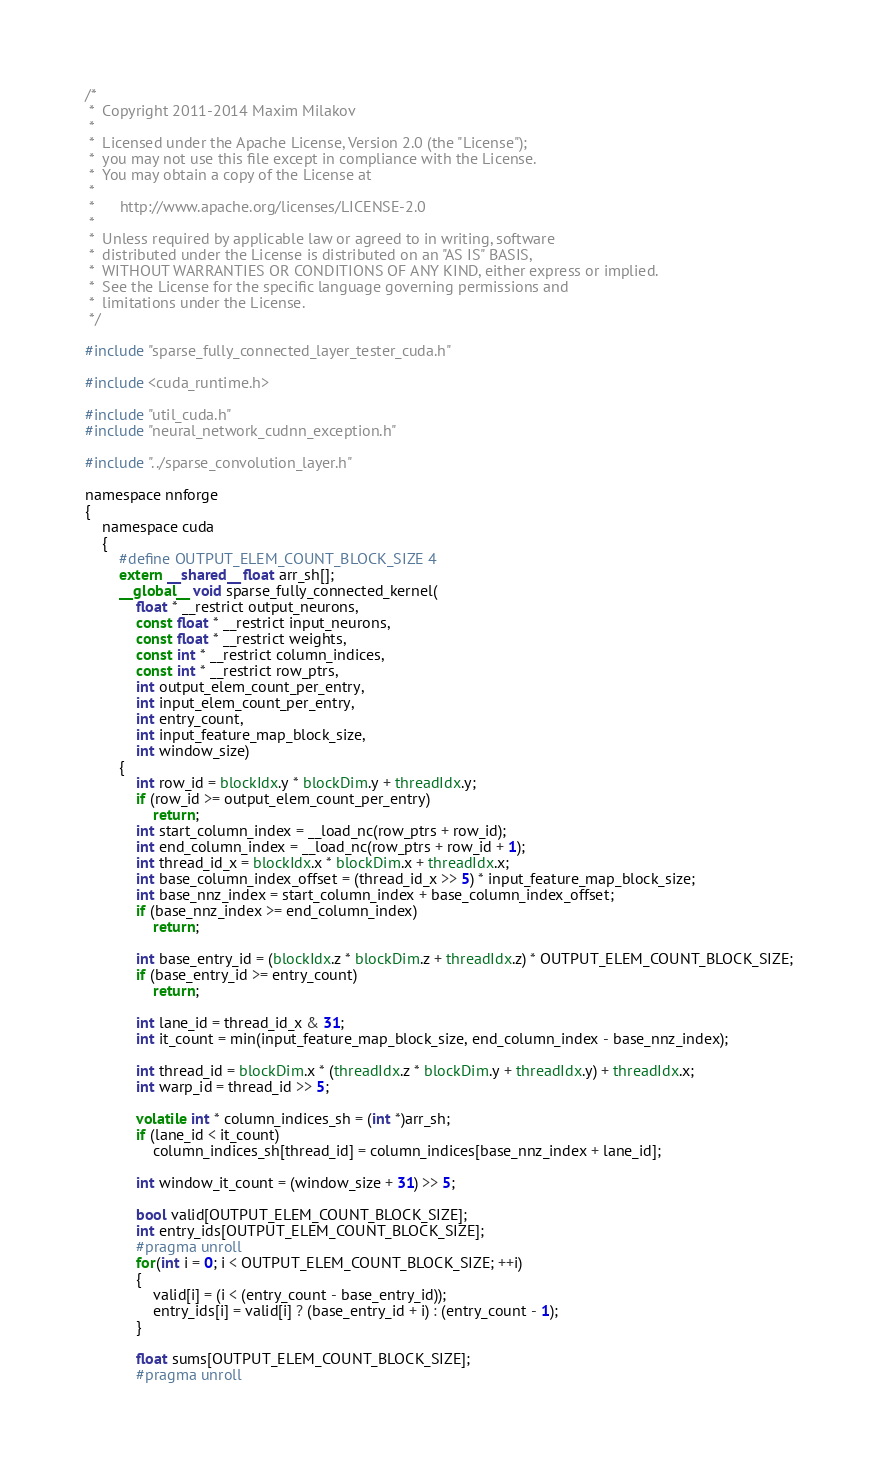Convert code to text. <code><loc_0><loc_0><loc_500><loc_500><_Cuda_>/*
 *  Copyright 2011-2014 Maxim Milakov
 *
 *  Licensed under the Apache License, Version 2.0 (the "License");
 *  you may not use this file except in compliance with the License.
 *  You may obtain a copy of the License at
 *
 *      http://www.apache.org/licenses/LICENSE-2.0
 *
 *  Unless required by applicable law or agreed to in writing, software
 *  distributed under the License is distributed on an "AS IS" BASIS,
 *  WITHOUT WARRANTIES OR CONDITIONS OF ANY KIND, either express or implied.
 *  See the License for the specific language governing permissions and
 *  limitations under the License.
 */

#include "sparse_fully_connected_layer_tester_cuda.h"

#include <cuda_runtime.h>

#include "util_cuda.h"
#include "neural_network_cudnn_exception.h"

#include "../sparse_convolution_layer.h"

namespace nnforge
{
	namespace cuda
	{
		#define OUTPUT_ELEM_COUNT_BLOCK_SIZE 4
		extern __shared__ float arr_sh[];
		__global__ void sparse_fully_connected_kernel(
			float * __restrict output_neurons,
			const float * __restrict input_neurons,
			const float * __restrict weights,
			const int * __restrict column_indices,
			const int * __restrict row_ptrs,
			int output_elem_count_per_entry,
			int input_elem_count_per_entry,
			int entry_count,
			int input_feature_map_block_size,
			int window_size)
		{
			int row_id = blockIdx.y * blockDim.y + threadIdx.y;
			if (row_id >= output_elem_count_per_entry)
				return;
			int start_column_index = __load_nc(row_ptrs + row_id);
			int end_column_index = __load_nc(row_ptrs + row_id + 1);
			int thread_id_x = blockIdx.x * blockDim.x + threadIdx.x;
			int base_column_index_offset = (thread_id_x >> 5) * input_feature_map_block_size;
			int base_nnz_index = start_column_index + base_column_index_offset;
			if (base_nnz_index >= end_column_index)
				return;

			int base_entry_id = (blockIdx.z * blockDim.z + threadIdx.z) * OUTPUT_ELEM_COUNT_BLOCK_SIZE;
			if (base_entry_id >= entry_count)
				return;

			int lane_id = thread_id_x & 31;
			int it_count = min(input_feature_map_block_size, end_column_index - base_nnz_index);

			int thread_id = blockDim.x * (threadIdx.z * blockDim.y + threadIdx.y) + threadIdx.x;
			int warp_id = thread_id >> 5;

			volatile int * column_indices_sh = (int *)arr_sh;
			if (lane_id < it_count)
				column_indices_sh[thread_id] = column_indices[base_nnz_index + lane_id];

			int window_it_count = (window_size + 31) >> 5;

			bool valid[OUTPUT_ELEM_COUNT_BLOCK_SIZE];
			int entry_ids[OUTPUT_ELEM_COUNT_BLOCK_SIZE];
			#pragma unroll
			for(int i = 0; i < OUTPUT_ELEM_COUNT_BLOCK_SIZE; ++i)
			{
				valid[i] = (i < (entry_count - base_entry_id));
				entry_ids[i] = valid[i] ? (base_entry_id + i) : (entry_count - 1);
			}

			float sums[OUTPUT_ELEM_COUNT_BLOCK_SIZE];
			#pragma unroll</code> 